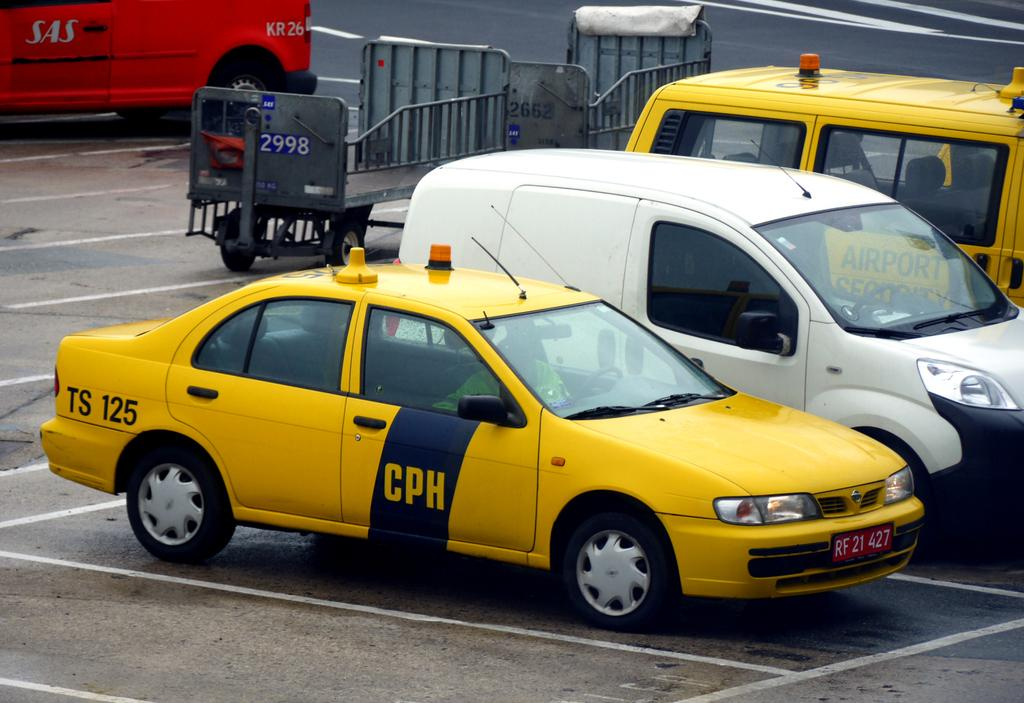<image>
Offer a succinct explanation of the picture presented. A yellow taxi with CPH on the door and TS 125 on the back. 